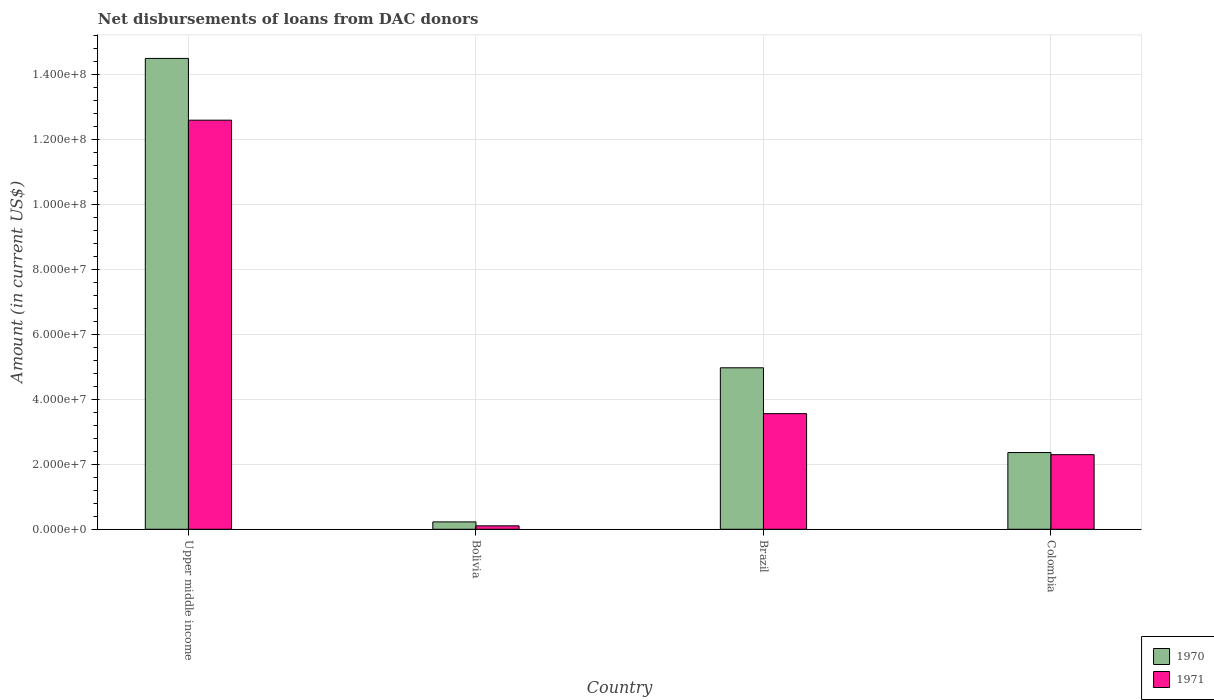How many different coloured bars are there?
Your answer should be compact. 2. How many groups of bars are there?
Offer a very short reply. 4. Are the number of bars on each tick of the X-axis equal?
Make the answer very short. Yes. How many bars are there on the 1st tick from the left?
Offer a very short reply. 2. How many bars are there on the 3rd tick from the right?
Your answer should be compact. 2. What is the label of the 2nd group of bars from the left?
Make the answer very short. Bolivia. What is the amount of loans disbursed in 1970 in Brazil?
Offer a terse response. 4.97e+07. Across all countries, what is the maximum amount of loans disbursed in 1971?
Your answer should be compact. 1.26e+08. Across all countries, what is the minimum amount of loans disbursed in 1970?
Your answer should be compact. 2.27e+06. In which country was the amount of loans disbursed in 1970 maximum?
Your response must be concise. Upper middle income. What is the total amount of loans disbursed in 1971 in the graph?
Offer a very short reply. 1.86e+08. What is the difference between the amount of loans disbursed in 1971 in Colombia and that in Upper middle income?
Offer a very short reply. -1.03e+08. What is the difference between the amount of loans disbursed in 1971 in Upper middle income and the amount of loans disbursed in 1970 in Bolivia?
Your response must be concise. 1.24e+08. What is the average amount of loans disbursed in 1971 per country?
Your answer should be very brief. 4.64e+07. What is the difference between the amount of loans disbursed of/in 1971 and amount of loans disbursed of/in 1970 in Bolivia?
Your answer should be compact. -1.21e+06. In how many countries, is the amount of loans disbursed in 1970 greater than 12000000 US$?
Provide a succinct answer. 3. What is the ratio of the amount of loans disbursed in 1970 in Brazil to that in Colombia?
Ensure brevity in your answer.  2.1. What is the difference between the highest and the second highest amount of loans disbursed in 1970?
Give a very brief answer. 1.21e+08. What is the difference between the highest and the lowest amount of loans disbursed in 1971?
Your answer should be compact. 1.25e+08. In how many countries, is the amount of loans disbursed in 1970 greater than the average amount of loans disbursed in 1970 taken over all countries?
Your answer should be compact. 1. What does the 1st bar from the right in Colombia represents?
Your answer should be very brief. 1971. How many bars are there?
Provide a short and direct response. 8. Are all the bars in the graph horizontal?
Your response must be concise. No. How many countries are there in the graph?
Provide a short and direct response. 4. What is the difference between two consecutive major ticks on the Y-axis?
Provide a short and direct response. 2.00e+07. What is the title of the graph?
Keep it short and to the point. Net disbursements of loans from DAC donors. Does "2010" appear as one of the legend labels in the graph?
Give a very brief answer. No. What is the label or title of the X-axis?
Keep it short and to the point. Country. What is the label or title of the Y-axis?
Make the answer very short. Amount (in current US$). What is the Amount (in current US$) in 1970 in Upper middle income?
Give a very brief answer. 1.45e+08. What is the Amount (in current US$) of 1971 in Upper middle income?
Make the answer very short. 1.26e+08. What is the Amount (in current US$) in 1970 in Bolivia?
Make the answer very short. 2.27e+06. What is the Amount (in current US$) in 1971 in Bolivia?
Keep it short and to the point. 1.06e+06. What is the Amount (in current US$) of 1970 in Brazil?
Your answer should be compact. 4.97e+07. What is the Amount (in current US$) in 1971 in Brazil?
Make the answer very short. 3.56e+07. What is the Amount (in current US$) of 1970 in Colombia?
Your response must be concise. 2.36e+07. What is the Amount (in current US$) in 1971 in Colombia?
Offer a terse response. 2.30e+07. Across all countries, what is the maximum Amount (in current US$) of 1970?
Make the answer very short. 1.45e+08. Across all countries, what is the maximum Amount (in current US$) of 1971?
Keep it short and to the point. 1.26e+08. Across all countries, what is the minimum Amount (in current US$) in 1970?
Ensure brevity in your answer.  2.27e+06. Across all countries, what is the minimum Amount (in current US$) of 1971?
Provide a short and direct response. 1.06e+06. What is the total Amount (in current US$) in 1970 in the graph?
Your answer should be compact. 2.21e+08. What is the total Amount (in current US$) of 1971 in the graph?
Make the answer very short. 1.86e+08. What is the difference between the Amount (in current US$) of 1970 in Upper middle income and that in Bolivia?
Ensure brevity in your answer.  1.43e+08. What is the difference between the Amount (in current US$) in 1971 in Upper middle income and that in Bolivia?
Provide a short and direct response. 1.25e+08. What is the difference between the Amount (in current US$) of 1970 in Upper middle income and that in Brazil?
Ensure brevity in your answer.  9.52e+07. What is the difference between the Amount (in current US$) in 1971 in Upper middle income and that in Brazil?
Give a very brief answer. 9.03e+07. What is the difference between the Amount (in current US$) in 1970 in Upper middle income and that in Colombia?
Provide a succinct answer. 1.21e+08. What is the difference between the Amount (in current US$) of 1971 in Upper middle income and that in Colombia?
Provide a succinct answer. 1.03e+08. What is the difference between the Amount (in current US$) of 1970 in Bolivia and that in Brazil?
Give a very brief answer. -4.74e+07. What is the difference between the Amount (in current US$) of 1971 in Bolivia and that in Brazil?
Give a very brief answer. -3.45e+07. What is the difference between the Amount (in current US$) of 1970 in Bolivia and that in Colombia?
Offer a very short reply. -2.13e+07. What is the difference between the Amount (in current US$) of 1971 in Bolivia and that in Colombia?
Provide a short and direct response. -2.19e+07. What is the difference between the Amount (in current US$) of 1970 in Brazil and that in Colombia?
Offer a very short reply. 2.61e+07. What is the difference between the Amount (in current US$) of 1971 in Brazil and that in Colombia?
Offer a very short reply. 1.26e+07. What is the difference between the Amount (in current US$) in 1970 in Upper middle income and the Amount (in current US$) in 1971 in Bolivia?
Offer a very short reply. 1.44e+08. What is the difference between the Amount (in current US$) in 1970 in Upper middle income and the Amount (in current US$) in 1971 in Brazil?
Make the answer very short. 1.09e+08. What is the difference between the Amount (in current US$) of 1970 in Upper middle income and the Amount (in current US$) of 1971 in Colombia?
Ensure brevity in your answer.  1.22e+08. What is the difference between the Amount (in current US$) of 1970 in Bolivia and the Amount (in current US$) of 1971 in Brazil?
Your answer should be compact. -3.33e+07. What is the difference between the Amount (in current US$) of 1970 in Bolivia and the Amount (in current US$) of 1971 in Colombia?
Offer a terse response. -2.07e+07. What is the difference between the Amount (in current US$) in 1970 in Brazil and the Amount (in current US$) in 1971 in Colombia?
Your response must be concise. 2.67e+07. What is the average Amount (in current US$) in 1970 per country?
Give a very brief answer. 5.51e+07. What is the average Amount (in current US$) in 1971 per country?
Your response must be concise. 4.64e+07. What is the difference between the Amount (in current US$) of 1970 and Amount (in current US$) of 1971 in Upper middle income?
Provide a succinct answer. 1.90e+07. What is the difference between the Amount (in current US$) of 1970 and Amount (in current US$) of 1971 in Bolivia?
Provide a short and direct response. 1.21e+06. What is the difference between the Amount (in current US$) of 1970 and Amount (in current US$) of 1971 in Brazil?
Offer a very short reply. 1.41e+07. What is the difference between the Amount (in current US$) of 1970 and Amount (in current US$) of 1971 in Colombia?
Offer a very short reply. 6.52e+05. What is the ratio of the Amount (in current US$) of 1970 in Upper middle income to that in Bolivia?
Provide a succinct answer. 63.85. What is the ratio of the Amount (in current US$) of 1971 in Upper middle income to that in Bolivia?
Provide a short and direct response. 119.02. What is the ratio of the Amount (in current US$) of 1970 in Upper middle income to that in Brazil?
Your answer should be very brief. 2.92. What is the ratio of the Amount (in current US$) of 1971 in Upper middle income to that in Brazil?
Ensure brevity in your answer.  3.54. What is the ratio of the Amount (in current US$) of 1970 in Upper middle income to that in Colombia?
Your answer should be compact. 6.14. What is the ratio of the Amount (in current US$) of 1971 in Upper middle income to that in Colombia?
Provide a short and direct response. 5.48. What is the ratio of the Amount (in current US$) in 1970 in Bolivia to that in Brazil?
Your answer should be compact. 0.05. What is the ratio of the Amount (in current US$) in 1971 in Bolivia to that in Brazil?
Your response must be concise. 0.03. What is the ratio of the Amount (in current US$) of 1970 in Bolivia to that in Colombia?
Make the answer very short. 0.1. What is the ratio of the Amount (in current US$) in 1971 in Bolivia to that in Colombia?
Keep it short and to the point. 0.05. What is the ratio of the Amount (in current US$) of 1970 in Brazil to that in Colombia?
Offer a terse response. 2.1. What is the ratio of the Amount (in current US$) in 1971 in Brazil to that in Colombia?
Provide a succinct answer. 1.55. What is the difference between the highest and the second highest Amount (in current US$) of 1970?
Make the answer very short. 9.52e+07. What is the difference between the highest and the second highest Amount (in current US$) of 1971?
Make the answer very short. 9.03e+07. What is the difference between the highest and the lowest Amount (in current US$) in 1970?
Keep it short and to the point. 1.43e+08. What is the difference between the highest and the lowest Amount (in current US$) of 1971?
Provide a short and direct response. 1.25e+08. 